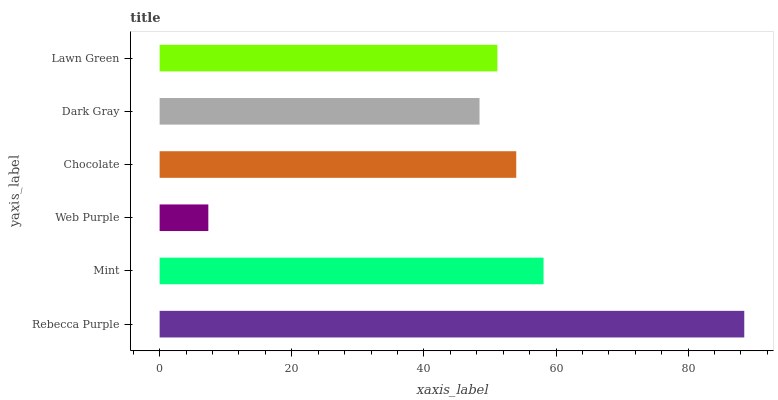Is Web Purple the minimum?
Answer yes or no. Yes. Is Rebecca Purple the maximum?
Answer yes or no. Yes. Is Mint the minimum?
Answer yes or no. No. Is Mint the maximum?
Answer yes or no. No. Is Rebecca Purple greater than Mint?
Answer yes or no. Yes. Is Mint less than Rebecca Purple?
Answer yes or no. Yes. Is Mint greater than Rebecca Purple?
Answer yes or no. No. Is Rebecca Purple less than Mint?
Answer yes or no. No. Is Chocolate the high median?
Answer yes or no. Yes. Is Lawn Green the low median?
Answer yes or no. Yes. Is Rebecca Purple the high median?
Answer yes or no. No. Is Dark Gray the low median?
Answer yes or no. No. 